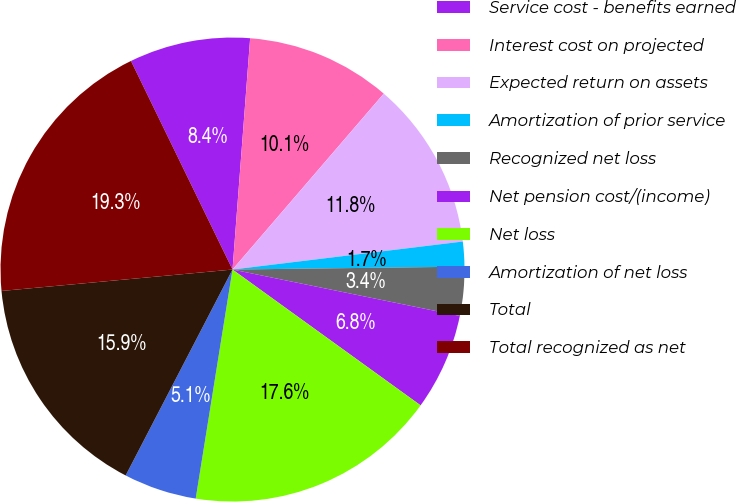Convert chart to OTSL. <chart><loc_0><loc_0><loc_500><loc_500><pie_chart><fcel>Service cost - benefits earned<fcel>Interest cost on projected<fcel>Expected return on assets<fcel>Amortization of prior service<fcel>Recognized net loss<fcel>Net pension cost/(income)<fcel>Net loss<fcel>Amortization of net loss<fcel>Total<fcel>Total recognized as net<nl><fcel>8.42%<fcel>10.09%<fcel>11.77%<fcel>1.73%<fcel>3.4%<fcel>6.75%<fcel>17.58%<fcel>5.08%<fcel>15.91%<fcel>19.26%<nl></chart> 